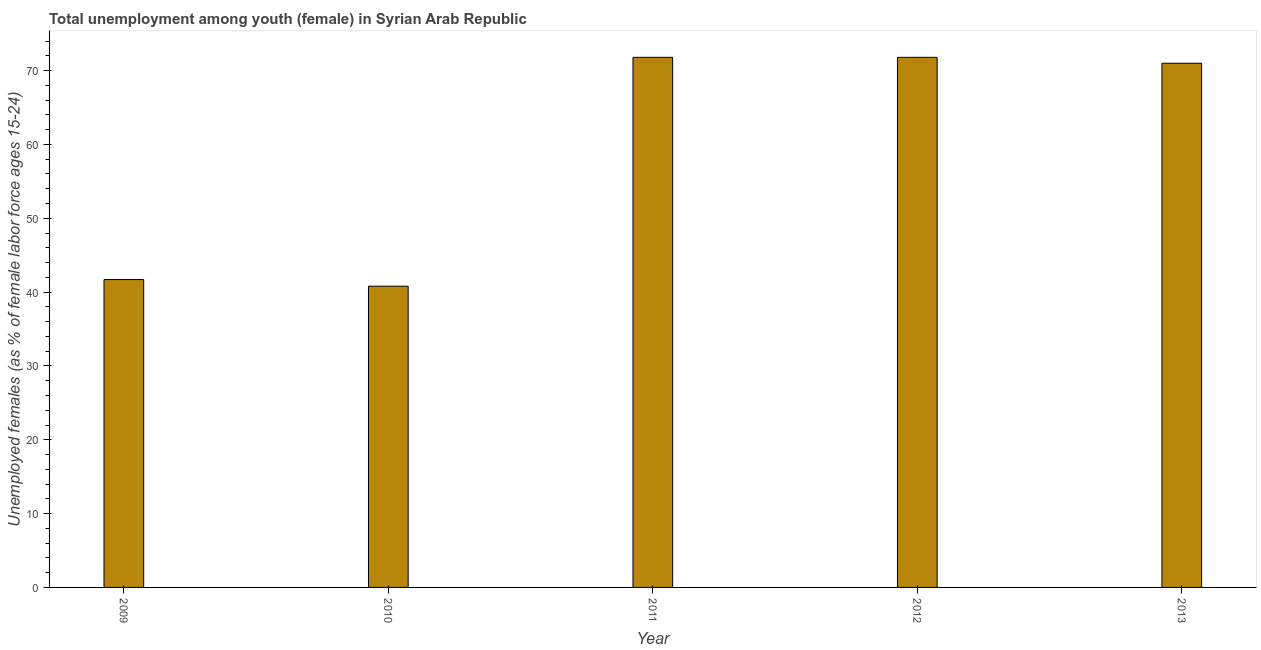Does the graph contain grids?
Your response must be concise. No. What is the title of the graph?
Give a very brief answer. Total unemployment among youth (female) in Syrian Arab Republic. What is the label or title of the X-axis?
Your answer should be very brief. Year. What is the label or title of the Y-axis?
Offer a terse response. Unemployed females (as % of female labor force ages 15-24). What is the unemployed female youth population in 2013?
Keep it short and to the point. 71. Across all years, what is the maximum unemployed female youth population?
Keep it short and to the point. 71.8. Across all years, what is the minimum unemployed female youth population?
Provide a succinct answer. 40.8. In which year was the unemployed female youth population maximum?
Make the answer very short. 2011. What is the sum of the unemployed female youth population?
Your answer should be compact. 297.1. What is the average unemployed female youth population per year?
Offer a very short reply. 59.42. What is the median unemployed female youth population?
Make the answer very short. 71. In how many years, is the unemployed female youth population greater than 8 %?
Provide a succinct answer. 5. Do a majority of the years between 2011 and 2010 (inclusive) have unemployed female youth population greater than 8 %?
Offer a terse response. No. What is the ratio of the unemployed female youth population in 2009 to that in 2013?
Your response must be concise. 0.59. Is the difference between the unemployed female youth population in 2009 and 2011 greater than the difference between any two years?
Make the answer very short. No. What is the difference between the highest and the second highest unemployed female youth population?
Give a very brief answer. 0. What is the difference between the highest and the lowest unemployed female youth population?
Keep it short and to the point. 31. In how many years, is the unemployed female youth population greater than the average unemployed female youth population taken over all years?
Your response must be concise. 3. How many bars are there?
Make the answer very short. 5. Are all the bars in the graph horizontal?
Provide a succinct answer. No. Are the values on the major ticks of Y-axis written in scientific E-notation?
Your answer should be very brief. No. What is the Unemployed females (as % of female labor force ages 15-24) in 2009?
Offer a very short reply. 41.7. What is the Unemployed females (as % of female labor force ages 15-24) of 2010?
Provide a short and direct response. 40.8. What is the Unemployed females (as % of female labor force ages 15-24) in 2011?
Your answer should be compact. 71.8. What is the Unemployed females (as % of female labor force ages 15-24) of 2012?
Keep it short and to the point. 71.8. What is the difference between the Unemployed females (as % of female labor force ages 15-24) in 2009 and 2011?
Your answer should be very brief. -30.1. What is the difference between the Unemployed females (as % of female labor force ages 15-24) in 2009 and 2012?
Provide a succinct answer. -30.1. What is the difference between the Unemployed females (as % of female labor force ages 15-24) in 2009 and 2013?
Offer a very short reply. -29.3. What is the difference between the Unemployed females (as % of female labor force ages 15-24) in 2010 and 2011?
Provide a short and direct response. -31. What is the difference between the Unemployed females (as % of female labor force ages 15-24) in 2010 and 2012?
Your answer should be compact. -31. What is the difference between the Unemployed females (as % of female labor force ages 15-24) in 2010 and 2013?
Offer a very short reply. -30.2. What is the difference between the Unemployed females (as % of female labor force ages 15-24) in 2011 and 2012?
Your answer should be very brief. 0. What is the difference between the Unemployed females (as % of female labor force ages 15-24) in 2012 and 2013?
Provide a succinct answer. 0.8. What is the ratio of the Unemployed females (as % of female labor force ages 15-24) in 2009 to that in 2010?
Make the answer very short. 1.02. What is the ratio of the Unemployed females (as % of female labor force ages 15-24) in 2009 to that in 2011?
Provide a short and direct response. 0.58. What is the ratio of the Unemployed females (as % of female labor force ages 15-24) in 2009 to that in 2012?
Keep it short and to the point. 0.58. What is the ratio of the Unemployed females (as % of female labor force ages 15-24) in 2009 to that in 2013?
Your answer should be very brief. 0.59. What is the ratio of the Unemployed females (as % of female labor force ages 15-24) in 2010 to that in 2011?
Your response must be concise. 0.57. What is the ratio of the Unemployed females (as % of female labor force ages 15-24) in 2010 to that in 2012?
Your answer should be compact. 0.57. What is the ratio of the Unemployed females (as % of female labor force ages 15-24) in 2010 to that in 2013?
Your answer should be compact. 0.57. What is the ratio of the Unemployed females (as % of female labor force ages 15-24) in 2011 to that in 2012?
Offer a terse response. 1. What is the ratio of the Unemployed females (as % of female labor force ages 15-24) in 2011 to that in 2013?
Your answer should be compact. 1.01. 